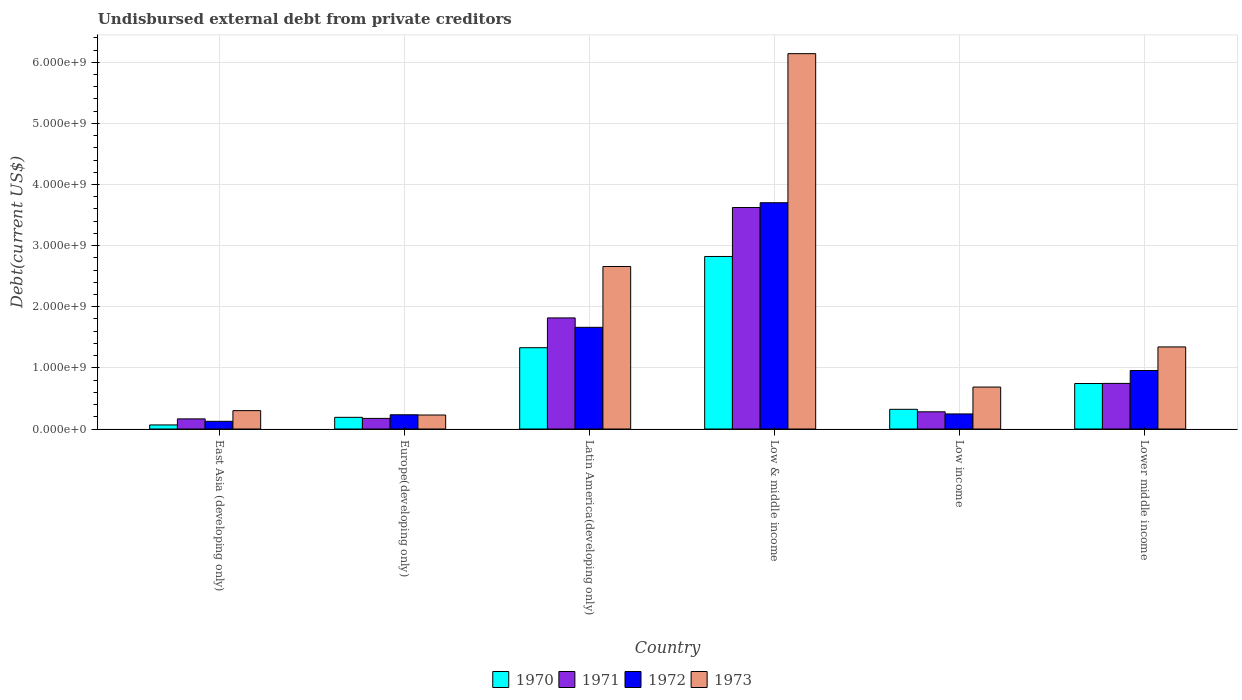How many different coloured bars are there?
Keep it short and to the point. 4. Are the number of bars per tick equal to the number of legend labels?
Provide a succinct answer. Yes. Are the number of bars on each tick of the X-axis equal?
Give a very brief answer. Yes. How many bars are there on the 6th tick from the right?
Offer a terse response. 4. What is the label of the 5th group of bars from the left?
Your response must be concise. Low income. In how many cases, is the number of bars for a given country not equal to the number of legend labels?
Offer a terse response. 0. What is the total debt in 1971 in Latin America(developing only)?
Your response must be concise. 1.82e+09. Across all countries, what is the maximum total debt in 1972?
Keep it short and to the point. 3.70e+09. Across all countries, what is the minimum total debt in 1970?
Your answer should be compact. 6.68e+07. In which country was the total debt in 1970 maximum?
Offer a very short reply. Low & middle income. In which country was the total debt in 1971 minimum?
Keep it short and to the point. East Asia (developing only). What is the total total debt in 1971 in the graph?
Ensure brevity in your answer.  6.81e+09. What is the difference between the total debt in 1971 in East Asia (developing only) and that in Europe(developing only)?
Make the answer very short. -7.94e+06. What is the difference between the total debt in 1971 in Latin America(developing only) and the total debt in 1972 in Lower middle income?
Give a very brief answer. 8.61e+08. What is the average total debt in 1972 per country?
Make the answer very short. 1.15e+09. What is the difference between the total debt of/in 1972 and total debt of/in 1973 in East Asia (developing only)?
Keep it short and to the point. -1.75e+08. In how many countries, is the total debt in 1972 greater than 1600000000 US$?
Ensure brevity in your answer.  2. What is the ratio of the total debt in 1971 in Latin America(developing only) to that in Low income?
Your response must be concise. 6.46. Is the total debt in 1972 in Europe(developing only) less than that in Lower middle income?
Offer a very short reply. Yes. What is the difference between the highest and the second highest total debt in 1972?
Your answer should be compact. -2.04e+09. What is the difference between the highest and the lowest total debt in 1970?
Keep it short and to the point. 2.76e+09. Is it the case that in every country, the sum of the total debt in 1973 and total debt in 1970 is greater than the sum of total debt in 1971 and total debt in 1972?
Ensure brevity in your answer.  No. What does the 3rd bar from the left in Low & middle income represents?
Give a very brief answer. 1972. What does the 2nd bar from the right in Low & middle income represents?
Offer a terse response. 1972. Is it the case that in every country, the sum of the total debt in 1973 and total debt in 1971 is greater than the total debt in 1972?
Ensure brevity in your answer.  Yes. How many bars are there?
Keep it short and to the point. 24. Are all the bars in the graph horizontal?
Provide a succinct answer. No. Are the values on the major ticks of Y-axis written in scientific E-notation?
Your response must be concise. Yes. Does the graph contain any zero values?
Provide a short and direct response. No. Does the graph contain grids?
Give a very brief answer. Yes. Where does the legend appear in the graph?
Your answer should be compact. Bottom center. How many legend labels are there?
Ensure brevity in your answer.  4. What is the title of the graph?
Your answer should be compact. Undisbursed external debt from private creditors. Does "2005" appear as one of the legend labels in the graph?
Your response must be concise. No. What is the label or title of the X-axis?
Your answer should be very brief. Country. What is the label or title of the Y-axis?
Keep it short and to the point. Debt(current US$). What is the Debt(current US$) of 1970 in East Asia (developing only)?
Keep it short and to the point. 6.68e+07. What is the Debt(current US$) of 1971 in East Asia (developing only)?
Ensure brevity in your answer.  1.66e+08. What is the Debt(current US$) in 1972 in East Asia (developing only)?
Keep it short and to the point. 1.26e+08. What is the Debt(current US$) of 1973 in East Asia (developing only)?
Provide a succinct answer. 3.01e+08. What is the Debt(current US$) of 1970 in Europe(developing only)?
Offer a very short reply. 1.91e+08. What is the Debt(current US$) of 1971 in Europe(developing only)?
Your answer should be compact. 1.74e+08. What is the Debt(current US$) of 1972 in Europe(developing only)?
Offer a very short reply. 2.33e+08. What is the Debt(current US$) of 1973 in Europe(developing only)?
Your answer should be compact. 2.29e+08. What is the Debt(current US$) in 1970 in Latin America(developing only)?
Your response must be concise. 1.33e+09. What is the Debt(current US$) of 1971 in Latin America(developing only)?
Give a very brief answer. 1.82e+09. What is the Debt(current US$) in 1972 in Latin America(developing only)?
Offer a terse response. 1.66e+09. What is the Debt(current US$) of 1973 in Latin America(developing only)?
Your answer should be very brief. 2.66e+09. What is the Debt(current US$) in 1970 in Low & middle income?
Give a very brief answer. 2.82e+09. What is the Debt(current US$) of 1971 in Low & middle income?
Your response must be concise. 3.62e+09. What is the Debt(current US$) in 1972 in Low & middle income?
Give a very brief answer. 3.70e+09. What is the Debt(current US$) in 1973 in Low & middle income?
Make the answer very short. 6.14e+09. What is the Debt(current US$) in 1970 in Low income?
Your answer should be compact. 3.22e+08. What is the Debt(current US$) of 1971 in Low income?
Offer a terse response. 2.82e+08. What is the Debt(current US$) in 1972 in Low income?
Make the answer very short. 2.47e+08. What is the Debt(current US$) of 1973 in Low income?
Your answer should be very brief. 6.86e+08. What is the Debt(current US$) of 1970 in Lower middle income?
Offer a terse response. 7.44e+08. What is the Debt(current US$) in 1971 in Lower middle income?
Make the answer very short. 7.46e+08. What is the Debt(current US$) in 1972 in Lower middle income?
Your answer should be compact. 9.57e+08. What is the Debt(current US$) of 1973 in Lower middle income?
Provide a short and direct response. 1.34e+09. Across all countries, what is the maximum Debt(current US$) in 1970?
Ensure brevity in your answer.  2.82e+09. Across all countries, what is the maximum Debt(current US$) in 1971?
Your answer should be compact. 3.62e+09. Across all countries, what is the maximum Debt(current US$) in 1972?
Ensure brevity in your answer.  3.70e+09. Across all countries, what is the maximum Debt(current US$) in 1973?
Make the answer very short. 6.14e+09. Across all countries, what is the minimum Debt(current US$) in 1970?
Give a very brief answer. 6.68e+07. Across all countries, what is the minimum Debt(current US$) in 1971?
Make the answer very short. 1.66e+08. Across all countries, what is the minimum Debt(current US$) of 1972?
Your response must be concise. 1.26e+08. Across all countries, what is the minimum Debt(current US$) in 1973?
Give a very brief answer. 2.29e+08. What is the total Debt(current US$) in 1970 in the graph?
Your response must be concise. 5.48e+09. What is the total Debt(current US$) in 1971 in the graph?
Provide a succinct answer. 6.81e+09. What is the total Debt(current US$) in 1972 in the graph?
Offer a very short reply. 6.93e+09. What is the total Debt(current US$) of 1973 in the graph?
Give a very brief answer. 1.14e+1. What is the difference between the Debt(current US$) of 1970 in East Asia (developing only) and that in Europe(developing only)?
Offer a very short reply. -1.24e+08. What is the difference between the Debt(current US$) of 1971 in East Asia (developing only) and that in Europe(developing only)?
Your response must be concise. -7.94e+06. What is the difference between the Debt(current US$) of 1972 in East Asia (developing only) and that in Europe(developing only)?
Your answer should be very brief. -1.07e+08. What is the difference between the Debt(current US$) of 1973 in East Asia (developing only) and that in Europe(developing only)?
Your answer should be compact. 7.16e+07. What is the difference between the Debt(current US$) in 1970 in East Asia (developing only) and that in Latin America(developing only)?
Give a very brief answer. -1.26e+09. What is the difference between the Debt(current US$) in 1971 in East Asia (developing only) and that in Latin America(developing only)?
Give a very brief answer. -1.65e+09. What is the difference between the Debt(current US$) of 1972 in East Asia (developing only) and that in Latin America(developing only)?
Provide a short and direct response. -1.54e+09. What is the difference between the Debt(current US$) in 1973 in East Asia (developing only) and that in Latin America(developing only)?
Offer a very short reply. -2.36e+09. What is the difference between the Debt(current US$) of 1970 in East Asia (developing only) and that in Low & middle income?
Your answer should be very brief. -2.76e+09. What is the difference between the Debt(current US$) in 1971 in East Asia (developing only) and that in Low & middle income?
Provide a short and direct response. -3.46e+09. What is the difference between the Debt(current US$) in 1972 in East Asia (developing only) and that in Low & middle income?
Your answer should be very brief. -3.58e+09. What is the difference between the Debt(current US$) of 1973 in East Asia (developing only) and that in Low & middle income?
Your answer should be compact. -5.84e+09. What is the difference between the Debt(current US$) in 1970 in East Asia (developing only) and that in Low income?
Ensure brevity in your answer.  -2.55e+08. What is the difference between the Debt(current US$) of 1971 in East Asia (developing only) and that in Low income?
Provide a succinct answer. -1.16e+08. What is the difference between the Debt(current US$) in 1972 in East Asia (developing only) and that in Low income?
Your answer should be very brief. -1.21e+08. What is the difference between the Debt(current US$) of 1973 in East Asia (developing only) and that in Low income?
Give a very brief answer. -3.86e+08. What is the difference between the Debt(current US$) in 1970 in East Asia (developing only) and that in Lower middle income?
Your answer should be compact. -6.77e+08. What is the difference between the Debt(current US$) in 1971 in East Asia (developing only) and that in Lower middle income?
Your answer should be compact. -5.81e+08. What is the difference between the Debt(current US$) in 1972 in East Asia (developing only) and that in Lower middle income?
Ensure brevity in your answer.  -8.31e+08. What is the difference between the Debt(current US$) in 1973 in East Asia (developing only) and that in Lower middle income?
Provide a short and direct response. -1.04e+09. What is the difference between the Debt(current US$) of 1970 in Europe(developing only) and that in Latin America(developing only)?
Offer a very short reply. -1.14e+09. What is the difference between the Debt(current US$) of 1971 in Europe(developing only) and that in Latin America(developing only)?
Offer a very short reply. -1.64e+09. What is the difference between the Debt(current US$) of 1972 in Europe(developing only) and that in Latin America(developing only)?
Keep it short and to the point. -1.43e+09. What is the difference between the Debt(current US$) in 1973 in Europe(developing only) and that in Latin America(developing only)?
Make the answer very short. -2.43e+09. What is the difference between the Debt(current US$) in 1970 in Europe(developing only) and that in Low & middle income?
Provide a short and direct response. -2.63e+09. What is the difference between the Debt(current US$) of 1971 in Europe(developing only) and that in Low & middle income?
Provide a short and direct response. -3.45e+09. What is the difference between the Debt(current US$) in 1972 in Europe(developing only) and that in Low & middle income?
Provide a succinct answer. -3.47e+09. What is the difference between the Debt(current US$) of 1973 in Europe(developing only) and that in Low & middle income?
Your response must be concise. -5.91e+09. What is the difference between the Debt(current US$) in 1970 in Europe(developing only) and that in Low income?
Your answer should be compact. -1.31e+08. What is the difference between the Debt(current US$) of 1971 in Europe(developing only) and that in Low income?
Provide a succinct answer. -1.08e+08. What is the difference between the Debt(current US$) in 1972 in Europe(developing only) and that in Low income?
Offer a terse response. -1.39e+07. What is the difference between the Debt(current US$) of 1973 in Europe(developing only) and that in Low income?
Ensure brevity in your answer.  -4.57e+08. What is the difference between the Debt(current US$) in 1970 in Europe(developing only) and that in Lower middle income?
Provide a short and direct response. -5.53e+08. What is the difference between the Debt(current US$) in 1971 in Europe(developing only) and that in Lower middle income?
Keep it short and to the point. -5.73e+08. What is the difference between the Debt(current US$) in 1972 in Europe(developing only) and that in Lower middle income?
Offer a terse response. -7.24e+08. What is the difference between the Debt(current US$) of 1973 in Europe(developing only) and that in Lower middle income?
Make the answer very short. -1.11e+09. What is the difference between the Debt(current US$) in 1970 in Latin America(developing only) and that in Low & middle income?
Keep it short and to the point. -1.49e+09. What is the difference between the Debt(current US$) in 1971 in Latin America(developing only) and that in Low & middle income?
Your answer should be very brief. -1.81e+09. What is the difference between the Debt(current US$) in 1972 in Latin America(developing only) and that in Low & middle income?
Your answer should be compact. -2.04e+09. What is the difference between the Debt(current US$) in 1973 in Latin America(developing only) and that in Low & middle income?
Give a very brief answer. -3.48e+09. What is the difference between the Debt(current US$) of 1970 in Latin America(developing only) and that in Low income?
Your answer should be compact. 1.01e+09. What is the difference between the Debt(current US$) in 1971 in Latin America(developing only) and that in Low income?
Make the answer very short. 1.54e+09. What is the difference between the Debt(current US$) of 1972 in Latin America(developing only) and that in Low income?
Keep it short and to the point. 1.42e+09. What is the difference between the Debt(current US$) of 1973 in Latin America(developing only) and that in Low income?
Give a very brief answer. 1.97e+09. What is the difference between the Debt(current US$) in 1970 in Latin America(developing only) and that in Lower middle income?
Your response must be concise. 5.86e+08. What is the difference between the Debt(current US$) in 1971 in Latin America(developing only) and that in Lower middle income?
Offer a terse response. 1.07e+09. What is the difference between the Debt(current US$) in 1972 in Latin America(developing only) and that in Lower middle income?
Ensure brevity in your answer.  7.07e+08. What is the difference between the Debt(current US$) in 1973 in Latin America(developing only) and that in Lower middle income?
Offer a very short reply. 1.32e+09. What is the difference between the Debt(current US$) of 1970 in Low & middle income and that in Low income?
Provide a succinct answer. 2.50e+09. What is the difference between the Debt(current US$) of 1971 in Low & middle income and that in Low income?
Offer a very short reply. 3.34e+09. What is the difference between the Debt(current US$) of 1972 in Low & middle income and that in Low income?
Give a very brief answer. 3.45e+09. What is the difference between the Debt(current US$) in 1973 in Low & middle income and that in Low income?
Your response must be concise. 5.45e+09. What is the difference between the Debt(current US$) in 1970 in Low & middle income and that in Lower middle income?
Provide a succinct answer. 2.08e+09. What is the difference between the Debt(current US$) in 1971 in Low & middle income and that in Lower middle income?
Offer a very short reply. 2.88e+09. What is the difference between the Debt(current US$) of 1972 in Low & middle income and that in Lower middle income?
Offer a very short reply. 2.74e+09. What is the difference between the Debt(current US$) in 1973 in Low & middle income and that in Lower middle income?
Keep it short and to the point. 4.80e+09. What is the difference between the Debt(current US$) in 1970 in Low income and that in Lower middle income?
Your response must be concise. -4.22e+08. What is the difference between the Debt(current US$) in 1971 in Low income and that in Lower middle income?
Give a very brief answer. -4.65e+08. What is the difference between the Debt(current US$) of 1972 in Low income and that in Lower middle income?
Your answer should be very brief. -7.10e+08. What is the difference between the Debt(current US$) of 1973 in Low income and that in Lower middle income?
Keep it short and to the point. -6.56e+08. What is the difference between the Debt(current US$) of 1970 in East Asia (developing only) and the Debt(current US$) of 1971 in Europe(developing only)?
Give a very brief answer. -1.07e+08. What is the difference between the Debt(current US$) in 1970 in East Asia (developing only) and the Debt(current US$) in 1972 in Europe(developing only)?
Keep it short and to the point. -1.66e+08. What is the difference between the Debt(current US$) in 1970 in East Asia (developing only) and the Debt(current US$) in 1973 in Europe(developing only)?
Provide a short and direct response. -1.62e+08. What is the difference between the Debt(current US$) in 1971 in East Asia (developing only) and the Debt(current US$) in 1972 in Europe(developing only)?
Offer a terse response. -6.72e+07. What is the difference between the Debt(current US$) of 1971 in East Asia (developing only) and the Debt(current US$) of 1973 in Europe(developing only)?
Your answer should be compact. -6.35e+07. What is the difference between the Debt(current US$) in 1972 in East Asia (developing only) and the Debt(current US$) in 1973 in Europe(developing only)?
Give a very brief answer. -1.03e+08. What is the difference between the Debt(current US$) of 1970 in East Asia (developing only) and the Debt(current US$) of 1971 in Latin America(developing only)?
Your answer should be compact. -1.75e+09. What is the difference between the Debt(current US$) of 1970 in East Asia (developing only) and the Debt(current US$) of 1972 in Latin America(developing only)?
Your response must be concise. -1.60e+09. What is the difference between the Debt(current US$) in 1970 in East Asia (developing only) and the Debt(current US$) in 1973 in Latin America(developing only)?
Your answer should be compact. -2.59e+09. What is the difference between the Debt(current US$) in 1971 in East Asia (developing only) and the Debt(current US$) in 1972 in Latin America(developing only)?
Your answer should be very brief. -1.50e+09. What is the difference between the Debt(current US$) of 1971 in East Asia (developing only) and the Debt(current US$) of 1973 in Latin America(developing only)?
Keep it short and to the point. -2.49e+09. What is the difference between the Debt(current US$) of 1972 in East Asia (developing only) and the Debt(current US$) of 1973 in Latin America(developing only)?
Offer a terse response. -2.53e+09. What is the difference between the Debt(current US$) in 1970 in East Asia (developing only) and the Debt(current US$) in 1971 in Low & middle income?
Keep it short and to the point. -3.56e+09. What is the difference between the Debt(current US$) in 1970 in East Asia (developing only) and the Debt(current US$) in 1972 in Low & middle income?
Offer a terse response. -3.63e+09. What is the difference between the Debt(current US$) of 1970 in East Asia (developing only) and the Debt(current US$) of 1973 in Low & middle income?
Your response must be concise. -6.07e+09. What is the difference between the Debt(current US$) in 1971 in East Asia (developing only) and the Debt(current US$) in 1972 in Low & middle income?
Ensure brevity in your answer.  -3.54e+09. What is the difference between the Debt(current US$) in 1971 in East Asia (developing only) and the Debt(current US$) in 1973 in Low & middle income?
Give a very brief answer. -5.97e+09. What is the difference between the Debt(current US$) of 1972 in East Asia (developing only) and the Debt(current US$) of 1973 in Low & middle income?
Make the answer very short. -6.01e+09. What is the difference between the Debt(current US$) of 1970 in East Asia (developing only) and the Debt(current US$) of 1971 in Low income?
Ensure brevity in your answer.  -2.15e+08. What is the difference between the Debt(current US$) in 1970 in East Asia (developing only) and the Debt(current US$) in 1972 in Low income?
Provide a succinct answer. -1.80e+08. What is the difference between the Debt(current US$) of 1970 in East Asia (developing only) and the Debt(current US$) of 1973 in Low income?
Keep it short and to the point. -6.20e+08. What is the difference between the Debt(current US$) in 1971 in East Asia (developing only) and the Debt(current US$) in 1972 in Low income?
Keep it short and to the point. -8.11e+07. What is the difference between the Debt(current US$) of 1971 in East Asia (developing only) and the Debt(current US$) of 1973 in Low income?
Give a very brief answer. -5.21e+08. What is the difference between the Debt(current US$) in 1972 in East Asia (developing only) and the Debt(current US$) in 1973 in Low income?
Your answer should be compact. -5.61e+08. What is the difference between the Debt(current US$) of 1970 in East Asia (developing only) and the Debt(current US$) of 1971 in Lower middle income?
Ensure brevity in your answer.  -6.79e+08. What is the difference between the Debt(current US$) of 1970 in East Asia (developing only) and the Debt(current US$) of 1972 in Lower middle income?
Your answer should be very brief. -8.90e+08. What is the difference between the Debt(current US$) in 1970 in East Asia (developing only) and the Debt(current US$) in 1973 in Lower middle income?
Ensure brevity in your answer.  -1.28e+09. What is the difference between the Debt(current US$) of 1971 in East Asia (developing only) and the Debt(current US$) of 1972 in Lower middle income?
Offer a terse response. -7.91e+08. What is the difference between the Debt(current US$) in 1971 in East Asia (developing only) and the Debt(current US$) in 1973 in Lower middle income?
Your answer should be compact. -1.18e+09. What is the difference between the Debt(current US$) of 1972 in East Asia (developing only) and the Debt(current US$) of 1973 in Lower middle income?
Your answer should be compact. -1.22e+09. What is the difference between the Debt(current US$) in 1970 in Europe(developing only) and the Debt(current US$) in 1971 in Latin America(developing only)?
Your answer should be very brief. -1.63e+09. What is the difference between the Debt(current US$) of 1970 in Europe(developing only) and the Debt(current US$) of 1972 in Latin America(developing only)?
Give a very brief answer. -1.47e+09. What is the difference between the Debt(current US$) of 1970 in Europe(developing only) and the Debt(current US$) of 1973 in Latin America(developing only)?
Your answer should be very brief. -2.47e+09. What is the difference between the Debt(current US$) in 1971 in Europe(developing only) and the Debt(current US$) in 1972 in Latin America(developing only)?
Your answer should be very brief. -1.49e+09. What is the difference between the Debt(current US$) of 1971 in Europe(developing only) and the Debt(current US$) of 1973 in Latin America(developing only)?
Give a very brief answer. -2.48e+09. What is the difference between the Debt(current US$) in 1972 in Europe(developing only) and the Debt(current US$) in 1973 in Latin America(developing only)?
Keep it short and to the point. -2.43e+09. What is the difference between the Debt(current US$) of 1970 in Europe(developing only) and the Debt(current US$) of 1971 in Low & middle income?
Keep it short and to the point. -3.43e+09. What is the difference between the Debt(current US$) of 1970 in Europe(developing only) and the Debt(current US$) of 1972 in Low & middle income?
Make the answer very short. -3.51e+09. What is the difference between the Debt(current US$) of 1970 in Europe(developing only) and the Debt(current US$) of 1973 in Low & middle income?
Give a very brief answer. -5.95e+09. What is the difference between the Debt(current US$) of 1971 in Europe(developing only) and the Debt(current US$) of 1972 in Low & middle income?
Provide a short and direct response. -3.53e+09. What is the difference between the Debt(current US$) of 1971 in Europe(developing only) and the Debt(current US$) of 1973 in Low & middle income?
Ensure brevity in your answer.  -5.97e+09. What is the difference between the Debt(current US$) of 1972 in Europe(developing only) and the Debt(current US$) of 1973 in Low & middle income?
Provide a short and direct response. -5.91e+09. What is the difference between the Debt(current US$) of 1970 in Europe(developing only) and the Debt(current US$) of 1971 in Low income?
Ensure brevity in your answer.  -9.05e+07. What is the difference between the Debt(current US$) of 1970 in Europe(developing only) and the Debt(current US$) of 1972 in Low income?
Keep it short and to the point. -5.58e+07. What is the difference between the Debt(current US$) of 1970 in Europe(developing only) and the Debt(current US$) of 1973 in Low income?
Your answer should be very brief. -4.95e+08. What is the difference between the Debt(current US$) in 1971 in Europe(developing only) and the Debt(current US$) in 1972 in Low income?
Your answer should be very brief. -7.31e+07. What is the difference between the Debt(current US$) in 1971 in Europe(developing only) and the Debt(current US$) in 1973 in Low income?
Make the answer very short. -5.13e+08. What is the difference between the Debt(current US$) in 1972 in Europe(developing only) and the Debt(current US$) in 1973 in Low income?
Provide a succinct answer. -4.54e+08. What is the difference between the Debt(current US$) of 1970 in Europe(developing only) and the Debt(current US$) of 1971 in Lower middle income?
Provide a short and direct response. -5.55e+08. What is the difference between the Debt(current US$) of 1970 in Europe(developing only) and the Debt(current US$) of 1972 in Lower middle income?
Ensure brevity in your answer.  -7.66e+08. What is the difference between the Debt(current US$) in 1970 in Europe(developing only) and the Debt(current US$) in 1973 in Lower middle income?
Your answer should be very brief. -1.15e+09. What is the difference between the Debt(current US$) in 1971 in Europe(developing only) and the Debt(current US$) in 1972 in Lower middle income?
Offer a terse response. -7.83e+08. What is the difference between the Debt(current US$) in 1971 in Europe(developing only) and the Debt(current US$) in 1973 in Lower middle income?
Provide a succinct answer. -1.17e+09. What is the difference between the Debt(current US$) in 1972 in Europe(developing only) and the Debt(current US$) in 1973 in Lower middle income?
Provide a succinct answer. -1.11e+09. What is the difference between the Debt(current US$) in 1970 in Latin America(developing only) and the Debt(current US$) in 1971 in Low & middle income?
Give a very brief answer. -2.29e+09. What is the difference between the Debt(current US$) of 1970 in Latin America(developing only) and the Debt(current US$) of 1972 in Low & middle income?
Give a very brief answer. -2.37e+09. What is the difference between the Debt(current US$) of 1970 in Latin America(developing only) and the Debt(current US$) of 1973 in Low & middle income?
Keep it short and to the point. -4.81e+09. What is the difference between the Debt(current US$) in 1971 in Latin America(developing only) and the Debt(current US$) in 1972 in Low & middle income?
Provide a succinct answer. -1.88e+09. What is the difference between the Debt(current US$) of 1971 in Latin America(developing only) and the Debt(current US$) of 1973 in Low & middle income?
Your answer should be compact. -4.32e+09. What is the difference between the Debt(current US$) in 1972 in Latin America(developing only) and the Debt(current US$) in 1973 in Low & middle income?
Offer a terse response. -4.48e+09. What is the difference between the Debt(current US$) in 1970 in Latin America(developing only) and the Debt(current US$) in 1971 in Low income?
Provide a succinct answer. 1.05e+09. What is the difference between the Debt(current US$) in 1970 in Latin America(developing only) and the Debt(current US$) in 1972 in Low income?
Give a very brief answer. 1.08e+09. What is the difference between the Debt(current US$) of 1970 in Latin America(developing only) and the Debt(current US$) of 1973 in Low income?
Your answer should be compact. 6.43e+08. What is the difference between the Debt(current US$) in 1971 in Latin America(developing only) and the Debt(current US$) in 1972 in Low income?
Provide a succinct answer. 1.57e+09. What is the difference between the Debt(current US$) in 1971 in Latin America(developing only) and the Debt(current US$) in 1973 in Low income?
Keep it short and to the point. 1.13e+09. What is the difference between the Debt(current US$) of 1972 in Latin America(developing only) and the Debt(current US$) of 1973 in Low income?
Provide a short and direct response. 9.77e+08. What is the difference between the Debt(current US$) in 1970 in Latin America(developing only) and the Debt(current US$) in 1971 in Lower middle income?
Your answer should be very brief. 5.84e+08. What is the difference between the Debt(current US$) in 1970 in Latin America(developing only) and the Debt(current US$) in 1972 in Lower middle income?
Offer a terse response. 3.73e+08. What is the difference between the Debt(current US$) in 1970 in Latin America(developing only) and the Debt(current US$) in 1973 in Lower middle income?
Provide a short and direct response. -1.29e+07. What is the difference between the Debt(current US$) in 1971 in Latin America(developing only) and the Debt(current US$) in 1972 in Lower middle income?
Offer a very short reply. 8.61e+08. What is the difference between the Debt(current US$) of 1971 in Latin America(developing only) and the Debt(current US$) of 1973 in Lower middle income?
Keep it short and to the point. 4.75e+08. What is the difference between the Debt(current US$) in 1972 in Latin America(developing only) and the Debt(current US$) in 1973 in Lower middle income?
Your answer should be very brief. 3.21e+08. What is the difference between the Debt(current US$) of 1970 in Low & middle income and the Debt(current US$) of 1971 in Low income?
Keep it short and to the point. 2.54e+09. What is the difference between the Debt(current US$) in 1970 in Low & middle income and the Debt(current US$) in 1972 in Low income?
Provide a succinct answer. 2.58e+09. What is the difference between the Debt(current US$) in 1970 in Low & middle income and the Debt(current US$) in 1973 in Low income?
Give a very brief answer. 2.14e+09. What is the difference between the Debt(current US$) in 1971 in Low & middle income and the Debt(current US$) in 1972 in Low income?
Your answer should be very brief. 3.38e+09. What is the difference between the Debt(current US$) in 1971 in Low & middle income and the Debt(current US$) in 1973 in Low income?
Provide a succinct answer. 2.94e+09. What is the difference between the Debt(current US$) in 1972 in Low & middle income and the Debt(current US$) in 1973 in Low income?
Ensure brevity in your answer.  3.02e+09. What is the difference between the Debt(current US$) of 1970 in Low & middle income and the Debt(current US$) of 1971 in Lower middle income?
Provide a succinct answer. 2.08e+09. What is the difference between the Debt(current US$) of 1970 in Low & middle income and the Debt(current US$) of 1972 in Lower middle income?
Give a very brief answer. 1.87e+09. What is the difference between the Debt(current US$) of 1970 in Low & middle income and the Debt(current US$) of 1973 in Lower middle income?
Offer a terse response. 1.48e+09. What is the difference between the Debt(current US$) in 1971 in Low & middle income and the Debt(current US$) in 1972 in Lower middle income?
Make the answer very short. 2.67e+09. What is the difference between the Debt(current US$) of 1971 in Low & middle income and the Debt(current US$) of 1973 in Lower middle income?
Make the answer very short. 2.28e+09. What is the difference between the Debt(current US$) of 1972 in Low & middle income and the Debt(current US$) of 1973 in Lower middle income?
Ensure brevity in your answer.  2.36e+09. What is the difference between the Debt(current US$) in 1970 in Low income and the Debt(current US$) in 1971 in Lower middle income?
Your answer should be compact. -4.24e+08. What is the difference between the Debt(current US$) in 1970 in Low income and the Debt(current US$) in 1972 in Lower middle income?
Your response must be concise. -6.35e+08. What is the difference between the Debt(current US$) in 1970 in Low income and the Debt(current US$) in 1973 in Lower middle income?
Offer a very short reply. -1.02e+09. What is the difference between the Debt(current US$) of 1971 in Low income and the Debt(current US$) of 1972 in Lower middle income?
Offer a terse response. -6.75e+08. What is the difference between the Debt(current US$) of 1971 in Low income and the Debt(current US$) of 1973 in Lower middle income?
Keep it short and to the point. -1.06e+09. What is the difference between the Debt(current US$) in 1972 in Low income and the Debt(current US$) in 1973 in Lower middle income?
Offer a very short reply. -1.10e+09. What is the average Debt(current US$) of 1970 per country?
Keep it short and to the point. 9.13e+08. What is the average Debt(current US$) in 1971 per country?
Provide a succinct answer. 1.13e+09. What is the average Debt(current US$) of 1972 per country?
Keep it short and to the point. 1.15e+09. What is the average Debt(current US$) of 1973 per country?
Give a very brief answer. 1.89e+09. What is the difference between the Debt(current US$) in 1970 and Debt(current US$) in 1971 in East Asia (developing only)?
Provide a short and direct response. -9.89e+07. What is the difference between the Debt(current US$) of 1970 and Debt(current US$) of 1972 in East Asia (developing only)?
Your response must be concise. -5.90e+07. What is the difference between the Debt(current US$) of 1970 and Debt(current US$) of 1973 in East Asia (developing only)?
Provide a short and direct response. -2.34e+08. What is the difference between the Debt(current US$) in 1971 and Debt(current US$) in 1972 in East Asia (developing only)?
Your response must be concise. 3.99e+07. What is the difference between the Debt(current US$) in 1971 and Debt(current US$) in 1973 in East Asia (developing only)?
Offer a very short reply. -1.35e+08. What is the difference between the Debt(current US$) in 1972 and Debt(current US$) in 1973 in East Asia (developing only)?
Offer a very short reply. -1.75e+08. What is the difference between the Debt(current US$) of 1970 and Debt(current US$) of 1971 in Europe(developing only)?
Keep it short and to the point. 1.74e+07. What is the difference between the Debt(current US$) in 1970 and Debt(current US$) in 1972 in Europe(developing only)?
Your response must be concise. -4.19e+07. What is the difference between the Debt(current US$) of 1970 and Debt(current US$) of 1973 in Europe(developing only)?
Your answer should be compact. -3.81e+07. What is the difference between the Debt(current US$) in 1971 and Debt(current US$) in 1972 in Europe(developing only)?
Your answer should be compact. -5.92e+07. What is the difference between the Debt(current US$) of 1971 and Debt(current US$) of 1973 in Europe(developing only)?
Give a very brief answer. -5.55e+07. What is the difference between the Debt(current US$) of 1972 and Debt(current US$) of 1973 in Europe(developing only)?
Ensure brevity in your answer.  3.73e+06. What is the difference between the Debt(current US$) of 1970 and Debt(current US$) of 1971 in Latin America(developing only)?
Your answer should be compact. -4.88e+08. What is the difference between the Debt(current US$) in 1970 and Debt(current US$) in 1972 in Latin America(developing only)?
Your answer should be very brief. -3.34e+08. What is the difference between the Debt(current US$) of 1970 and Debt(current US$) of 1973 in Latin America(developing only)?
Provide a short and direct response. -1.33e+09. What is the difference between the Debt(current US$) in 1971 and Debt(current US$) in 1972 in Latin America(developing only)?
Offer a very short reply. 1.54e+08. What is the difference between the Debt(current US$) in 1971 and Debt(current US$) in 1973 in Latin America(developing only)?
Give a very brief answer. -8.41e+08. What is the difference between the Debt(current US$) of 1972 and Debt(current US$) of 1973 in Latin America(developing only)?
Provide a short and direct response. -9.95e+08. What is the difference between the Debt(current US$) of 1970 and Debt(current US$) of 1971 in Low & middle income?
Provide a short and direct response. -8.01e+08. What is the difference between the Debt(current US$) in 1970 and Debt(current US$) in 1972 in Low & middle income?
Give a very brief answer. -8.79e+08. What is the difference between the Debt(current US$) in 1970 and Debt(current US$) in 1973 in Low & middle income?
Your answer should be compact. -3.32e+09. What is the difference between the Debt(current US$) of 1971 and Debt(current US$) of 1972 in Low & middle income?
Keep it short and to the point. -7.84e+07. What is the difference between the Debt(current US$) in 1971 and Debt(current US$) in 1973 in Low & middle income?
Your answer should be very brief. -2.52e+09. What is the difference between the Debt(current US$) of 1972 and Debt(current US$) of 1973 in Low & middle income?
Provide a succinct answer. -2.44e+09. What is the difference between the Debt(current US$) in 1970 and Debt(current US$) in 1971 in Low income?
Keep it short and to the point. 4.06e+07. What is the difference between the Debt(current US$) in 1970 and Debt(current US$) in 1972 in Low income?
Give a very brief answer. 7.53e+07. What is the difference between the Debt(current US$) in 1970 and Debt(current US$) in 1973 in Low income?
Keep it short and to the point. -3.64e+08. What is the difference between the Debt(current US$) of 1971 and Debt(current US$) of 1972 in Low income?
Give a very brief answer. 3.47e+07. What is the difference between the Debt(current US$) in 1971 and Debt(current US$) in 1973 in Low income?
Make the answer very short. -4.05e+08. What is the difference between the Debt(current US$) of 1972 and Debt(current US$) of 1973 in Low income?
Offer a terse response. -4.40e+08. What is the difference between the Debt(current US$) in 1970 and Debt(current US$) in 1971 in Lower middle income?
Make the answer very short. -2.10e+06. What is the difference between the Debt(current US$) in 1970 and Debt(current US$) in 1972 in Lower middle income?
Ensure brevity in your answer.  -2.13e+08. What is the difference between the Debt(current US$) of 1970 and Debt(current US$) of 1973 in Lower middle income?
Keep it short and to the point. -5.99e+08. What is the difference between the Debt(current US$) in 1971 and Debt(current US$) in 1972 in Lower middle income?
Your response must be concise. -2.11e+08. What is the difference between the Debt(current US$) of 1971 and Debt(current US$) of 1973 in Lower middle income?
Your response must be concise. -5.97e+08. What is the difference between the Debt(current US$) of 1972 and Debt(current US$) of 1973 in Lower middle income?
Give a very brief answer. -3.86e+08. What is the ratio of the Debt(current US$) of 1970 in East Asia (developing only) to that in Europe(developing only)?
Offer a very short reply. 0.35. What is the ratio of the Debt(current US$) in 1971 in East Asia (developing only) to that in Europe(developing only)?
Make the answer very short. 0.95. What is the ratio of the Debt(current US$) in 1972 in East Asia (developing only) to that in Europe(developing only)?
Provide a short and direct response. 0.54. What is the ratio of the Debt(current US$) of 1973 in East Asia (developing only) to that in Europe(developing only)?
Your response must be concise. 1.31. What is the ratio of the Debt(current US$) of 1970 in East Asia (developing only) to that in Latin America(developing only)?
Your answer should be very brief. 0.05. What is the ratio of the Debt(current US$) of 1971 in East Asia (developing only) to that in Latin America(developing only)?
Give a very brief answer. 0.09. What is the ratio of the Debt(current US$) in 1972 in East Asia (developing only) to that in Latin America(developing only)?
Ensure brevity in your answer.  0.08. What is the ratio of the Debt(current US$) of 1973 in East Asia (developing only) to that in Latin America(developing only)?
Keep it short and to the point. 0.11. What is the ratio of the Debt(current US$) of 1970 in East Asia (developing only) to that in Low & middle income?
Give a very brief answer. 0.02. What is the ratio of the Debt(current US$) in 1971 in East Asia (developing only) to that in Low & middle income?
Offer a terse response. 0.05. What is the ratio of the Debt(current US$) in 1972 in East Asia (developing only) to that in Low & middle income?
Your answer should be compact. 0.03. What is the ratio of the Debt(current US$) of 1973 in East Asia (developing only) to that in Low & middle income?
Offer a terse response. 0.05. What is the ratio of the Debt(current US$) in 1970 in East Asia (developing only) to that in Low income?
Provide a short and direct response. 0.21. What is the ratio of the Debt(current US$) of 1971 in East Asia (developing only) to that in Low income?
Your answer should be very brief. 0.59. What is the ratio of the Debt(current US$) in 1972 in East Asia (developing only) to that in Low income?
Offer a terse response. 0.51. What is the ratio of the Debt(current US$) in 1973 in East Asia (developing only) to that in Low income?
Offer a terse response. 0.44. What is the ratio of the Debt(current US$) in 1970 in East Asia (developing only) to that in Lower middle income?
Make the answer very short. 0.09. What is the ratio of the Debt(current US$) in 1971 in East Asia (developing only) to that in Lower middle income?
Make the answer very short. 0.22. What is the ratio of the Debt(current US$) in 1972 in East Asia (developing only) to that in Lower middle income?
Your answer should be very brief. 0.13. What is the ratio of the Debt(current US$) in 1973 in East Asia (developing only) to that in Lower middle income?
Provide a succinct answer. 0.22. What is the ratio of the Debt(current US$) in 1970 in Europe(developing only) to that in Latin America(developing only)?
Your answer should be very brief. 0.14. What is the ratio of the Debt(current US$) of 1971 in Europe(developing only) to that in Latin America(developing only)?
Make the answer very short. 0.1. What is the ratio of the Debt(current US$) of 1972 in Europe(developing only) to that in Latin America(developing only)?
Provide a short and direct response. 0.14. What is the ratio of the Debt(current US$) in 1973 in Europe(developing only) to that in Latin America(developing only)?
Your answer should be compact. 0.09. What is the ratio of the Debt(current US$) in 1970 in Europe(developing only) to that in Low & middle income?
Provide a succinct answer. 0.07. What is the ratio of the Debt(current US$) in 1971 in Europe(developing only) to that in Low & middle income?
Your answer should be very brief. 0.05. What is the ratio of the Debt(current US$) in 1972 in Europe(developing only) to that in Low & middle income?
Ensure brevity in your answer.  0.06. What is the ratio of the Debt(current US$) in 1973 in Europe(developing only) to that in Low & middle income?
Your answer should be very brief. 0.04. What is the ratio of the Debt(current US$) of 1970 in Europe(developing only) to that in Low income?
Offer a very short reply. 0.59. What is the ratio of the Debt(current US$) of 1971 in Europe(developing only) to that in Low income?
Provide a succinct answer. 0.62. What is the ratio of the Debt(current US$) of 1972 in Europe(developing only) to that in Low income?
Your answer should be very brief. 0.94. What is the ratio of the Debt(current US$) of 1973 in Europe(developing only) to that in Low income?
Your response must be concise. 0.33. What is the ratio of the Debt(current US$) in 1970 in Europe(developing only) to that in Lower middle income?
Make the answer very short. 0.26. What is the ratio of the Debt(current US$) of 1971 in Europe(developing only) to that in Lower middle income?
Your answer should be compact. 0.23. What is the ratio of the Debt(current US$) in 1972 in Europe(developing only) to that in Lower middle income?
Your answer should be compact. 0.24. What is the ratio of the Debt(current US$) in 1973 in Europe(developing only) to that in Lower middle income?
Your answer should be compact. 0.17. What is the ratio of the Debt(current US$) in 1970 in Latin America(developing only) to that in Low & middle income?
Your answer should be compact. 0.47. What is the ratio of the Debt(current US$) of 1971 in Latin America(developing only) to that in Low & middle income?
Give a very brief answer. 0.5. What is the ratio of the Debt(current US$) in 1972 in Latin America(developing only) to that in Low & middle income?
Your response must be concise. 0.45. What is the ratio of the Debt(current US$) of 1973 in Latin America(developing only) to that in Low & middle income?
Your answer should be very brief. 0.43. What is the ratio of the Debt(current US$) of 1970 in Latin America(developing only) to that in Low income?
Ensure brevity in your answer.  4.13. What is the ratio of the Debt(current US$) of 1971 in Latin America(developing only) to that in Low income?
Give a very brief answer. 6.46. What is the ratio of the Debt(current US$) in 1972 in Latin America(developing only) to that in Low income?
Your answer should be very brief. 6.74. What is the ratio of the Debt(current US$) of 1973 in Latin America(developing only) to that in Low income?
Provide a short and direct response. 3.87. What is the ratio of the Debt(current US$) in 1970 in Latin America(developing only) to that in Lower middle income?
Offer a terse response. 1.79. What is the ratio of the Debt(current US$) in 1971 in Latin America(developing only) to that in Lower middle income?
Ensure brevity in your answer.  2.44. What is the ratio of the Debt(current US$) in 1972 in Latin America(developing only) to that in Lower middle income?
Your answer should be very brief. 1.74. What is the ratio of the Debt(current US$) of 1973 in Latin America(developing only) to that in Lower middle income?
Offer a terse response. 1.98. What is the ratio of the Debt(current US$) of 1970 in Low & middle income to that in Low income?
Provide a short and direct response. 8.76. What is the ratio of the Debt(current US$) in 1971 in Low & middle income to that in Low income?
Make the answer very short. 12.87. What is the ratio of the Debt(current US$) of 1972 in Low & middle income to that in Low income?
Provide a succinct answer. 15. What is the ratio of the Debt(current US$) of 1973 in Low & middle income to that in Low income?
Your response must be concise. 8.95. What is the ratio of the Debt(current US$) of 1970 in Low & middle income to that in Lower middle income?
Your answer should be very brief. 3.79. What is the ratio of the Debt(current US$) in 1971 in Low & middle income to that in Lower middle income?
Your response must be concise. 4.86. What is the ratio of the Debt(current US$) of 1972 in Low & middle income to that in Lower middle income?
Offer a very short reply. 3.87. What is the ratio of the Debt(current US$) in 1973 in Low & middle income to that in Lower middle income?
Keep it short and to the point. 4.57. What is the ratio of the Debt(current US$) of 1970 in Low income to that in Lower middle income?
Provide a short and direct response. 0.43. What is the ratio of the Debt(current US$) of 1971 in Low income to that in Lower middle income?
Keep it short and to the point. 0.38. What is the ratio of the Debt(current US$) of 1972 in Low income to that in Lower middle income?
Make the answer very short. 0.26. What is the ratio of the Debt(current US$) in 1973 in Low income to that in Lower middle income?
Keep it short and to the point. 0.51. What is the difference between the highest and the second highest Debt(current US$) in 1970?
Your answer should be very brief. 1.49e+09. What is the difference between the highest and the second highest Debt(current US$) in 1971?
Your answer should be compact. 1.81e+09. What is the difference between the highest and the second highest Debt(current US$) in 1972?
Make the answer very short. 2.04e+09. What is the difference between the highest and the second highest Debt(current US$) in 1973?
Provide a short and direct response. 3.48e+09. What is the difference between the highest and the lowest Debt(current US$) in 1970?
Make the answer very short. 2.76e+09. What is the difference between the highest and the lowest Debt(current US$) in 1971?
Your answer should be very brief. 3.46e+09. What is the difference between the highest and the lowest Debt(current US$) of 1972?
Offer a very short reply. 3.58e+09. What is the difference between the highest and the lowest Debt(current US$) in 1973?
Your response must be concise. 5.91e+09. 